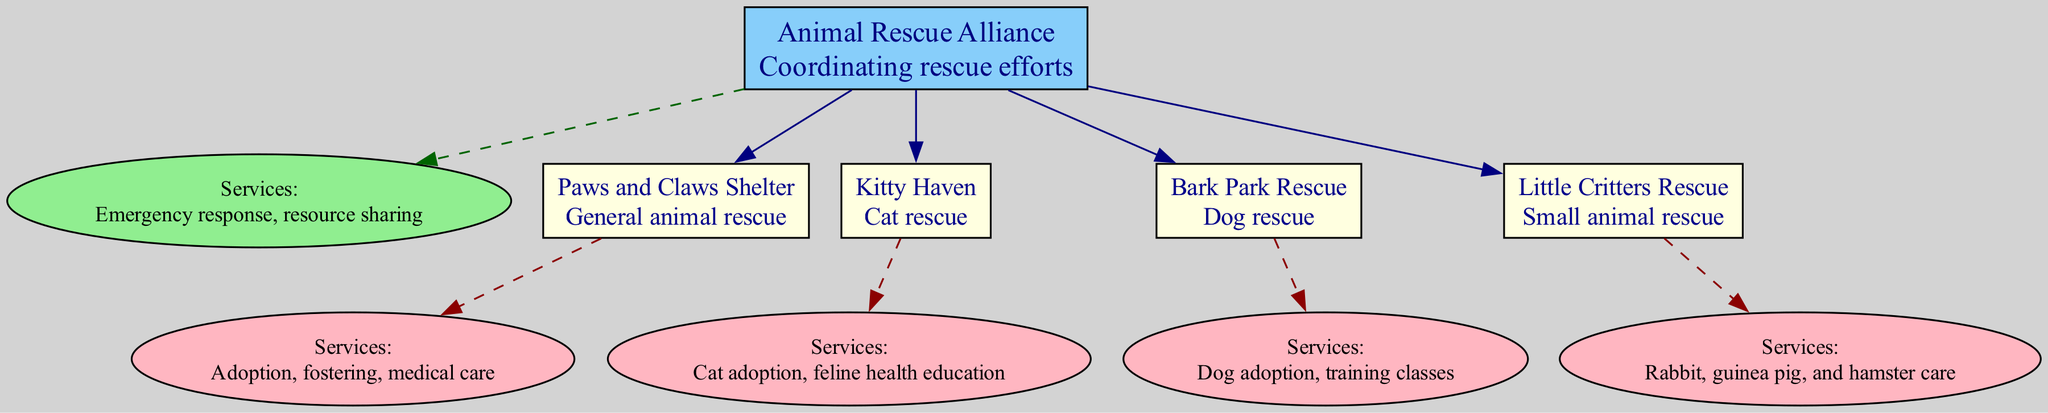What is the focus of the Animal Rescue Alliance? The diagram shows that the Animal Rescue Alliance has a focus on "Coordinating rescue efforts." This information is clearly labeled next to the name of the organization.
Answer: Coordinating rescue efforts How many branches does the Animal Rescue Alliance have? By counting the branches listed under the Animal Rescue Alliance, we see that there are four distinct branches: Paws and Claws Shelter, Kitty Haven, Bark Park Rescue, and Little Critters Rescue.
Answer: 4 What services does Kitty Haven provide? The diagram specifies that Kitty Haven offers services related to "Cat adoption" and "feline health education." This information is shown directly in the branch services area for Kitty Haven.
Answer: Cat adoption, feline health education What is the focus of Bark Park Rescue? Looking at the diagram, Bark Park Rescue has a focus on "Dog rescue." This information is located adjacent to the branch name.
Answer: Dog rescue Which branch focuses on small animals? The diagram indicates that "Little Critters Rescue" focuses on small animal rescue, specifically rabbits, guinea pigs, and hamsters. This is stated under Little Critters Rescue in the diagram.
Answer: Little Critters Rescue What services does Paws and Claws Shelter offer? According to the diagram, Paws and Claws Shelter offers "Adoption," "fostering," and "medical care." This information is labeled directly next to the shelter's name under services.
Answer: Adoption, fostering, medical care Which organization has a focus on cat rescue? From the branches shown in the diagram, Kitty Haven is identified as the organization that has a focus on cat rescue. This is where it is specified in the focus area of the diagram.
Answer: Kitty Haven What type of animals does Little Critters Rescue care for? The diagram specifies that Little Critters Rescue cares for small animals, specifically mentioning rabbits, guinea pigs, and hamsters. This is clear from the information given in the branch description.
Answer: Rabbits, guinea pigs, hamsters What is the main goal of the Animal Rescue Alliance? The main goal, or focus, of the Animal Rescue Alliance is stated as "Coordinating rescue efforts." This foundational goal is provided at the top of the family tree diagram.
Answer: Coordinating rescue efforts 